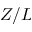<formula> <loc_0><loc_0><loc_500><loc_500>Z / L</formula> 